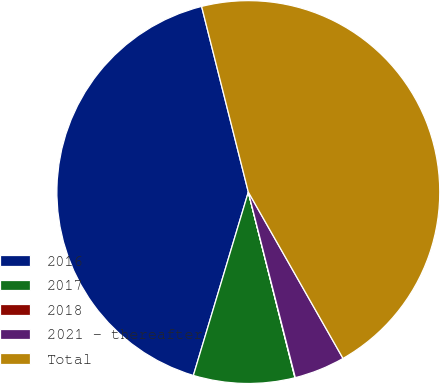<chart> <loc_0><loc_0><loc_500><loc_500><pie_chart><fcel>2016<fcel>2017<fcel>2018<fcel>2021 - thereafter<fcel>Total<nl><fcel>41.44%<fcel>8.55%<fcel>0.03%<fcel>4.29%<fcel>45.69%<nl></chart> 